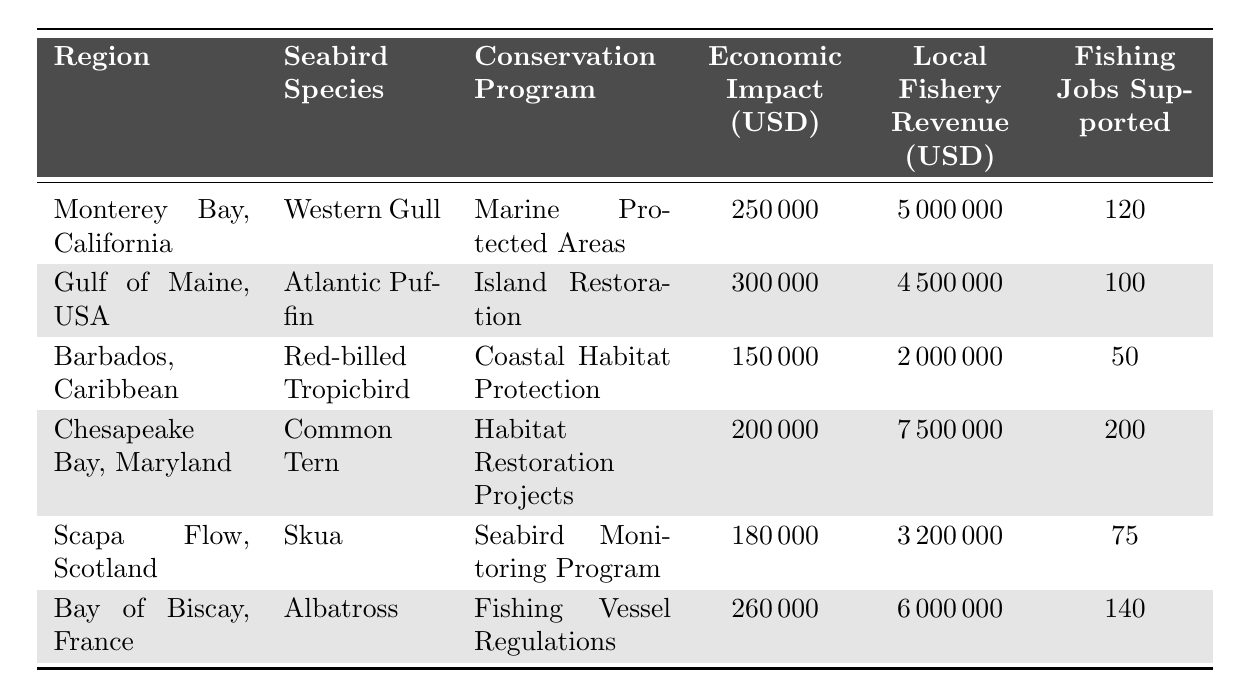What is the economic impact of the Western Gull conservation program? According to the table, the economic impact of the Western Gull conservation program in Monterey Bay, California is listed as 250,000 USD.
Answer: 250,000 USD Which region has the highest economic impact from seabird conservation? By comparing the economic impacts listed in the table, Gulf of Maine, with an economic impact of 300,000 USD, has the highest economic impact from seabird conservation.
Answer: Gulf of Maine, USA How many fishing jobs are supported in Chesapeake Bay, Maryland? The table indicates that Chesapeake Bay, Maryland, supports 200 fishing jobs.
Answer: 200 What is the total local fishery revenue in the Bay of Biscay, France? According to the table, the local fishery revenue in the Bay of Biscay, France is 6,000,000 USD.
Answer: 6,000,000 USD What is the average economic impact across all regions in the table? To find the average economic impact, we sum the individual impacts: 250,000 + 300,000 + 150,000 + 200,000 + 180,000 + 260,000 = 1,340,000 USD. There are 6 regions, so the average is 1,340,000 / 6 = 223,333.33 USD.
Answer: 223,333.33 USD Is the economic impact of the Common Tern conservation program greater than 200,000 USD? The table shows that the economic impact of the Common Tern conservation program is exactly 200,000 USD, thus it is not greater than this amount.
Answer: No Which conservation program supports the least number of fishing jobs? By looking at the number of fishing jobs supported for each seabird conservation program, the Red-billed Tropicbird in Barbados supports the least amount with 50 jobs.
Answer: Coastal Habitat Protection What is the combined local fishery revenue for regions with seabird species that have an economic impact of over 200,000 USD? The regions with an economic impact over 200,000 USD are: Gulf of Maine (4,500,000 USD), Chesapeake Bay (7,500,000 USD), and Bay of Biscay (6,000,000 USD). Summing these gives 4,500,000 + 7,500,000 + 6,000,000 = 18,000,000 USD.
Answer: 18,000,000 USD Does the conservation program for the Albatross have a higher economic impact than that of the Skua? The economic impact for Albatross is 260,000 USD and for Skua, it is 180,000 USD. Since 260,000 USD is greater than 180,000 USD, the statement is true.
Answer: Yes If we rank the regions by the number of fishing jobs supported, which region falls in the middle position? The number of fishing jobs supported ranked from highest to lowest is: Chesapeake Bay (200), Bay of Biscay (140), Monterey Bay (120), Gulf of Maine (100), Scapa Flow (75), and Barbados (50). The middle position rank is 120 jobs for Monterey Bay.
Answer: Monterey Bay, California 